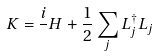Convert formula to latex. <formula><loc_0><loc_0><loc_500><loc_500>K = \frac { i } { } H + \frac { 1 } { 2 } \sum _ { j } L ^ { \dagger } _ { j } L _ { j }</formula> 